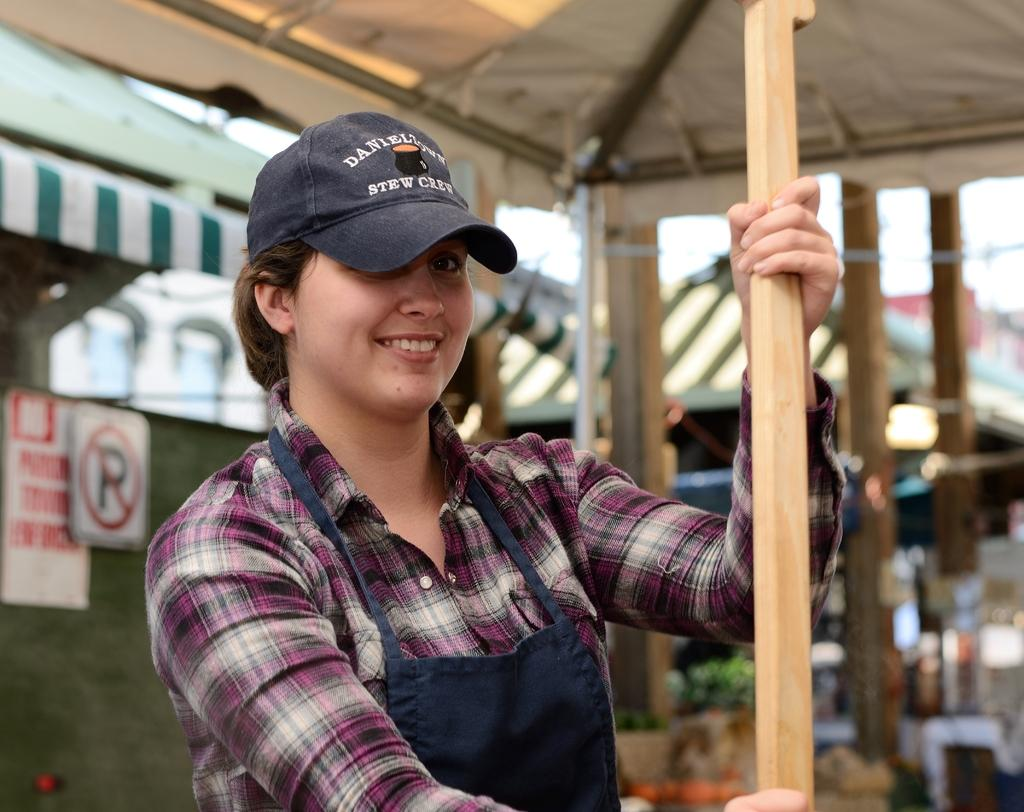Who is present in the image? There is a woman in the image. What is the woman wearing on her head? The woman is wearing a hat. What is the woman holding in her hand? The woman is holding a stick. Where is the woman standing in the image? The woman is standing under a tent. What can be seen on the boards in the image? There are boards with text in the image. How many tents are visible in the image? There are tents in the image. What architectural features can be seen in the image? There are pillars in the image. What is visible in the background of the image? The sky is visible in the image. How many chickens are sitting in the basket next to the woman in the image? There is no basket or chickens present in the image. 